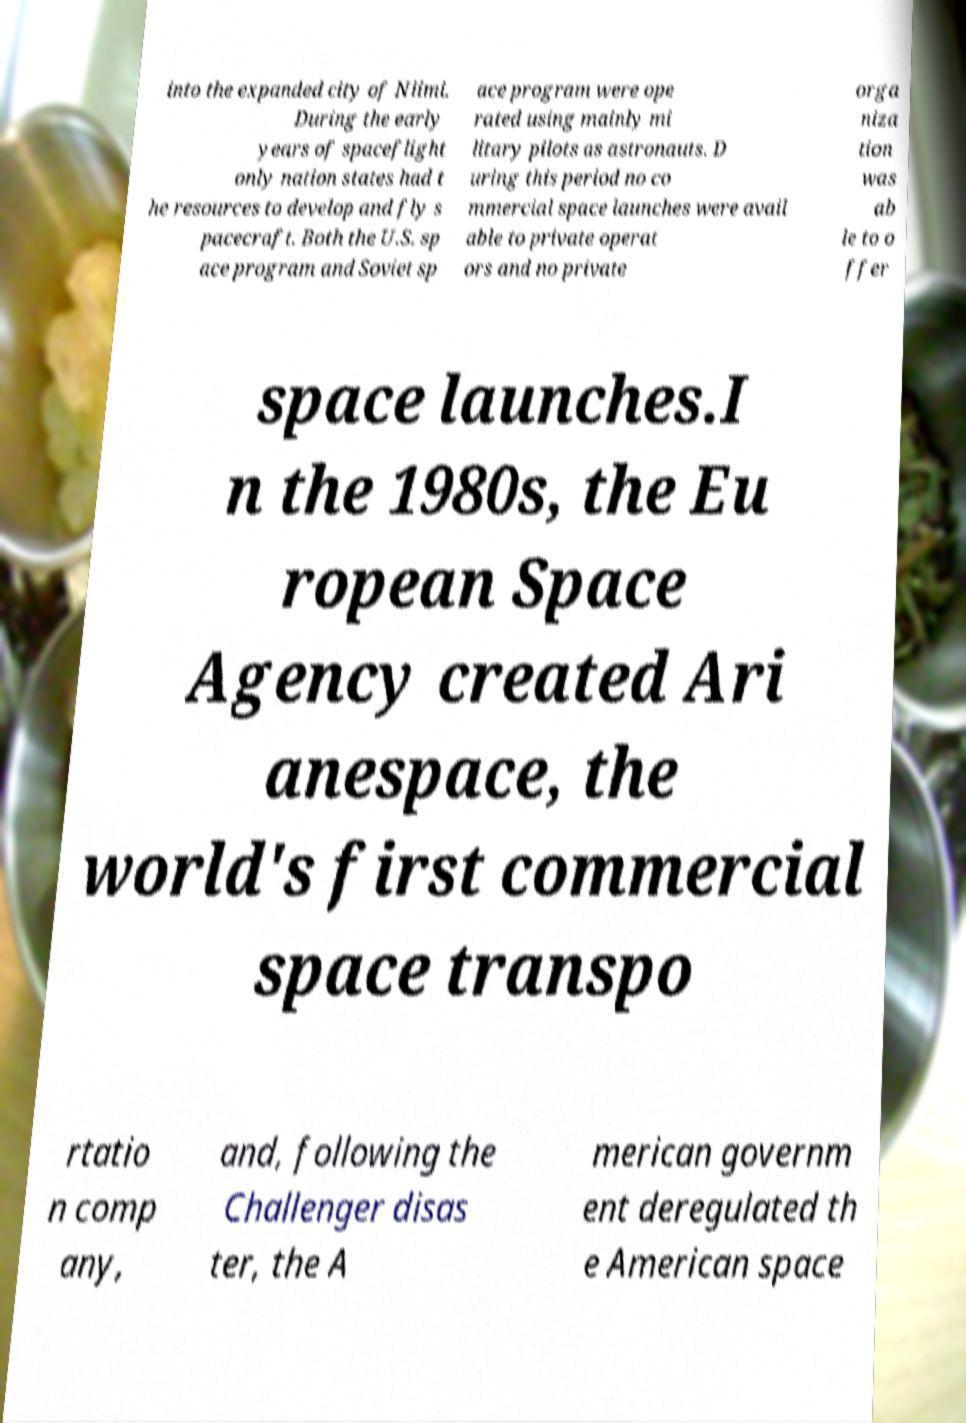For documentation purposes, I need the text within this image transcribed. Could you provide that? into the expanded city of Niimi. During the early years of spaceflight only nation states had t he resources to develop and fly s pacecraft. Both the U.S. sp ace program and Soviet sp ace program were ope rated using mainly mi litary pilots as astronauts. D uring this period no co mmercial space launches were avail able to private operat ors and no private orga niza tion was ab le to o ffer space launches.I n the 1980s, the Eu ropean Space Agency created Ari anespace, the world's first commercial space transpo rtatio n comp any, and, following the Challenger disas ter, the A merican governm ent deregulated th e American space 